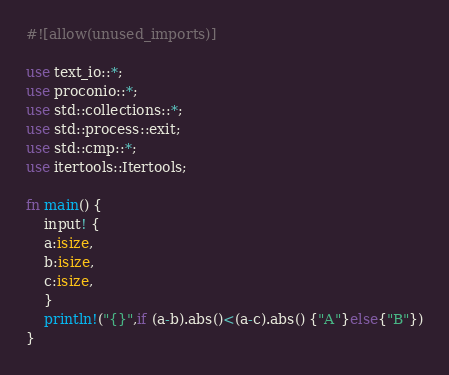Convert code to text. <code><loc_0><loc_0><loc_500><loc_500><_Rust_>#![allow(unused_imports)]

use text_io::*;
use proconio::*;
use std::collections::*;
use std::process::exit;
use std::cmp::*;
use itertools::Itertools;

fn main() {
    input! {
    a:isize,
    b:isize,
    c:isize,
    }
    println!("{}",if (a-b).abs()<(a-c).abs() {"A"}else{"B"})
}</code> 